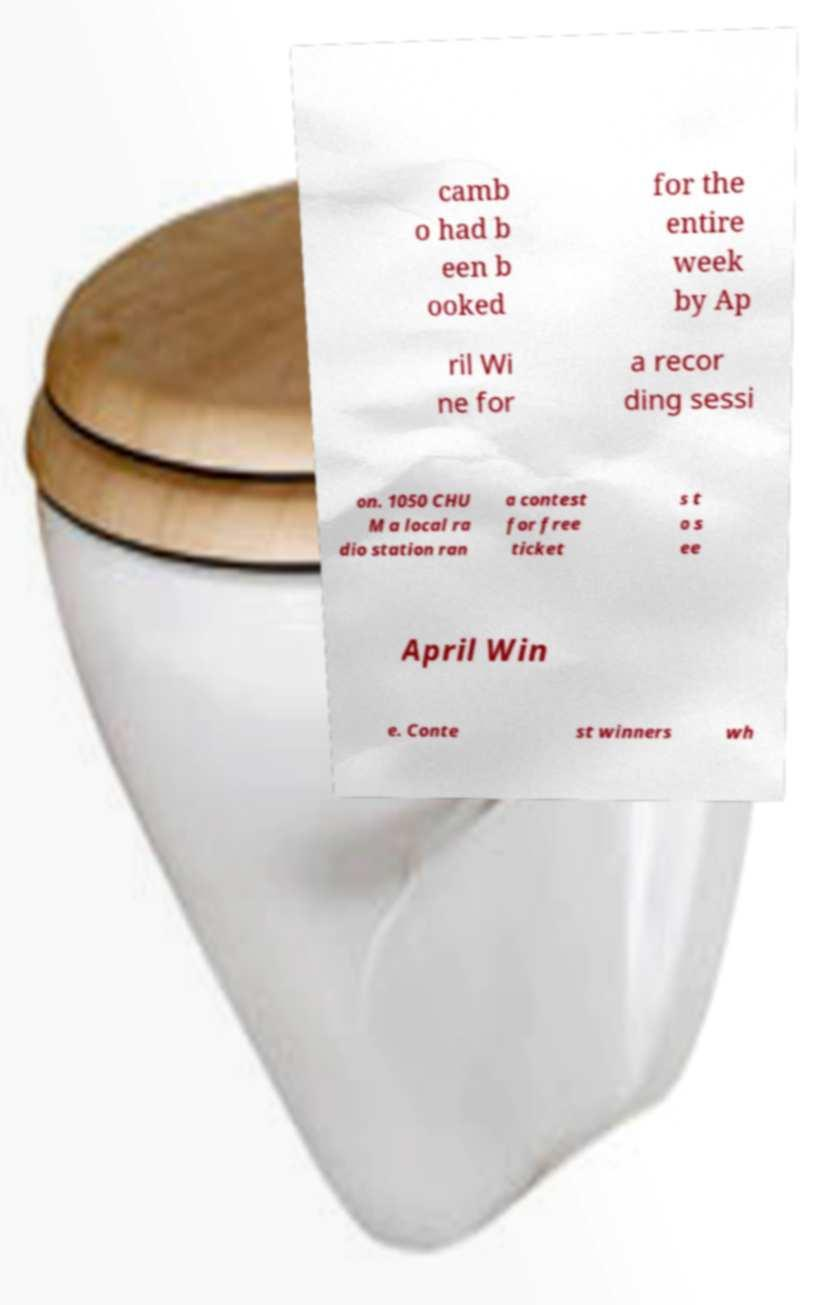I need the written content from this picture converted into text. Can you do that? camb o had b een b ooked for the entire week by Ap ril Wi ne for a recor ding sessi on. 1050 CHU M a local ra dio station ran a contest for free ticket s t o s ee April Win e. Conte st winners wh 